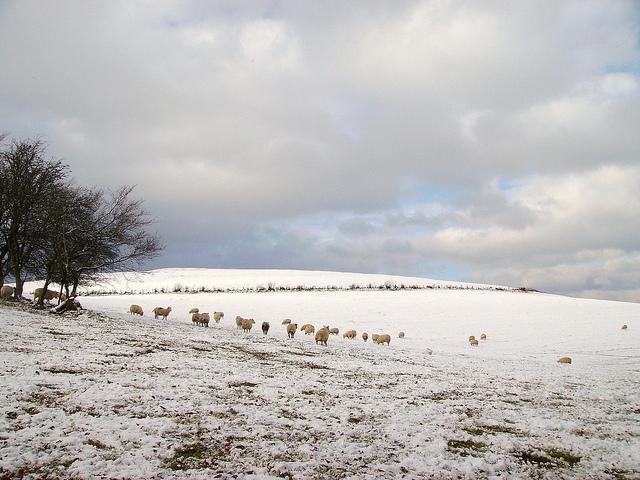How many sheep are there?
Give a very brief answer. 1. 